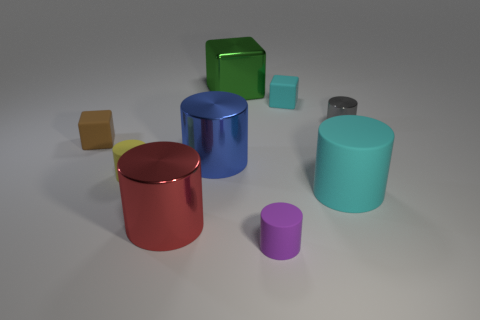Does the big block have the same color as the tiny shiny thing?
Keep it short and to the point. No. Is the number of green metal things in front of the green metallic object greater than the number of cyan rubber cylinders?
Offer a terse response. No. There is a purple object that is the same material as the large cyan object; what size is it?
Ensure brevity in your answer.  Small. How many small matte cubes are the same color as the metal block?
Your answer should be very brief. 0. Do the tiny block right of the big green metallic cube and the large rubber thing have the same color?
Provide a short and direct response. Yes. Are there the same number of tiny gray shiny cylinders that are left of the red object and large cylinders to the right of the big cyan object?
Your response must be concise. Yes. Is there anything else that is the same material as the yellow thing?
Offer a very short reply. Yes. There is a small thing in front of the cyan matte cylinder; what color is it?
Your answer should be very brief. Purple. Are there an equal number of big green shiny cubes behind the green block and big cyan rubber cylinders?
Your answer should be compact. No. What number of other things are the same shape as the red shiny object?
Provide a succinct answer. 5. 